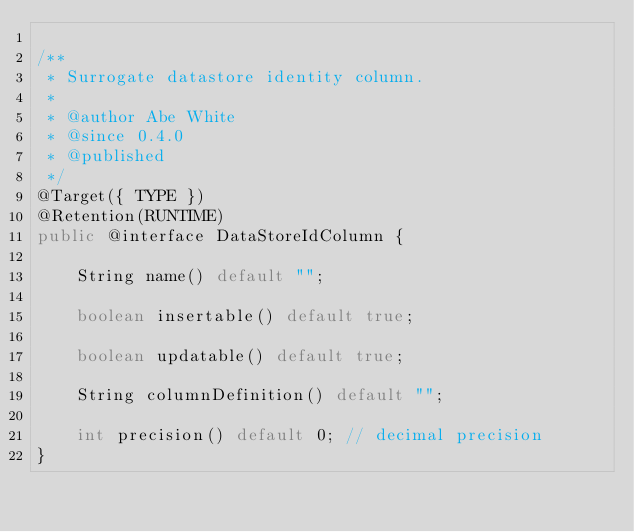Convert code to text. <code><loc_0><loc_0><loc_500><loc_500><_Java_>
/**
 * Surrogate datastore identity column.
 *
 * @author Abe White
 * @since 0.4.0
 * @published
 */
@Target({ TYPE })
@Retention(RUNTIME)
public @interface DataStoreIdColumn {

    String name() default "";

    boolean insertable() default true;

    boolean updatable() default true;

    String columnDefinition() default "";

    int precision() default 0; // decimal precision
}
</code> 